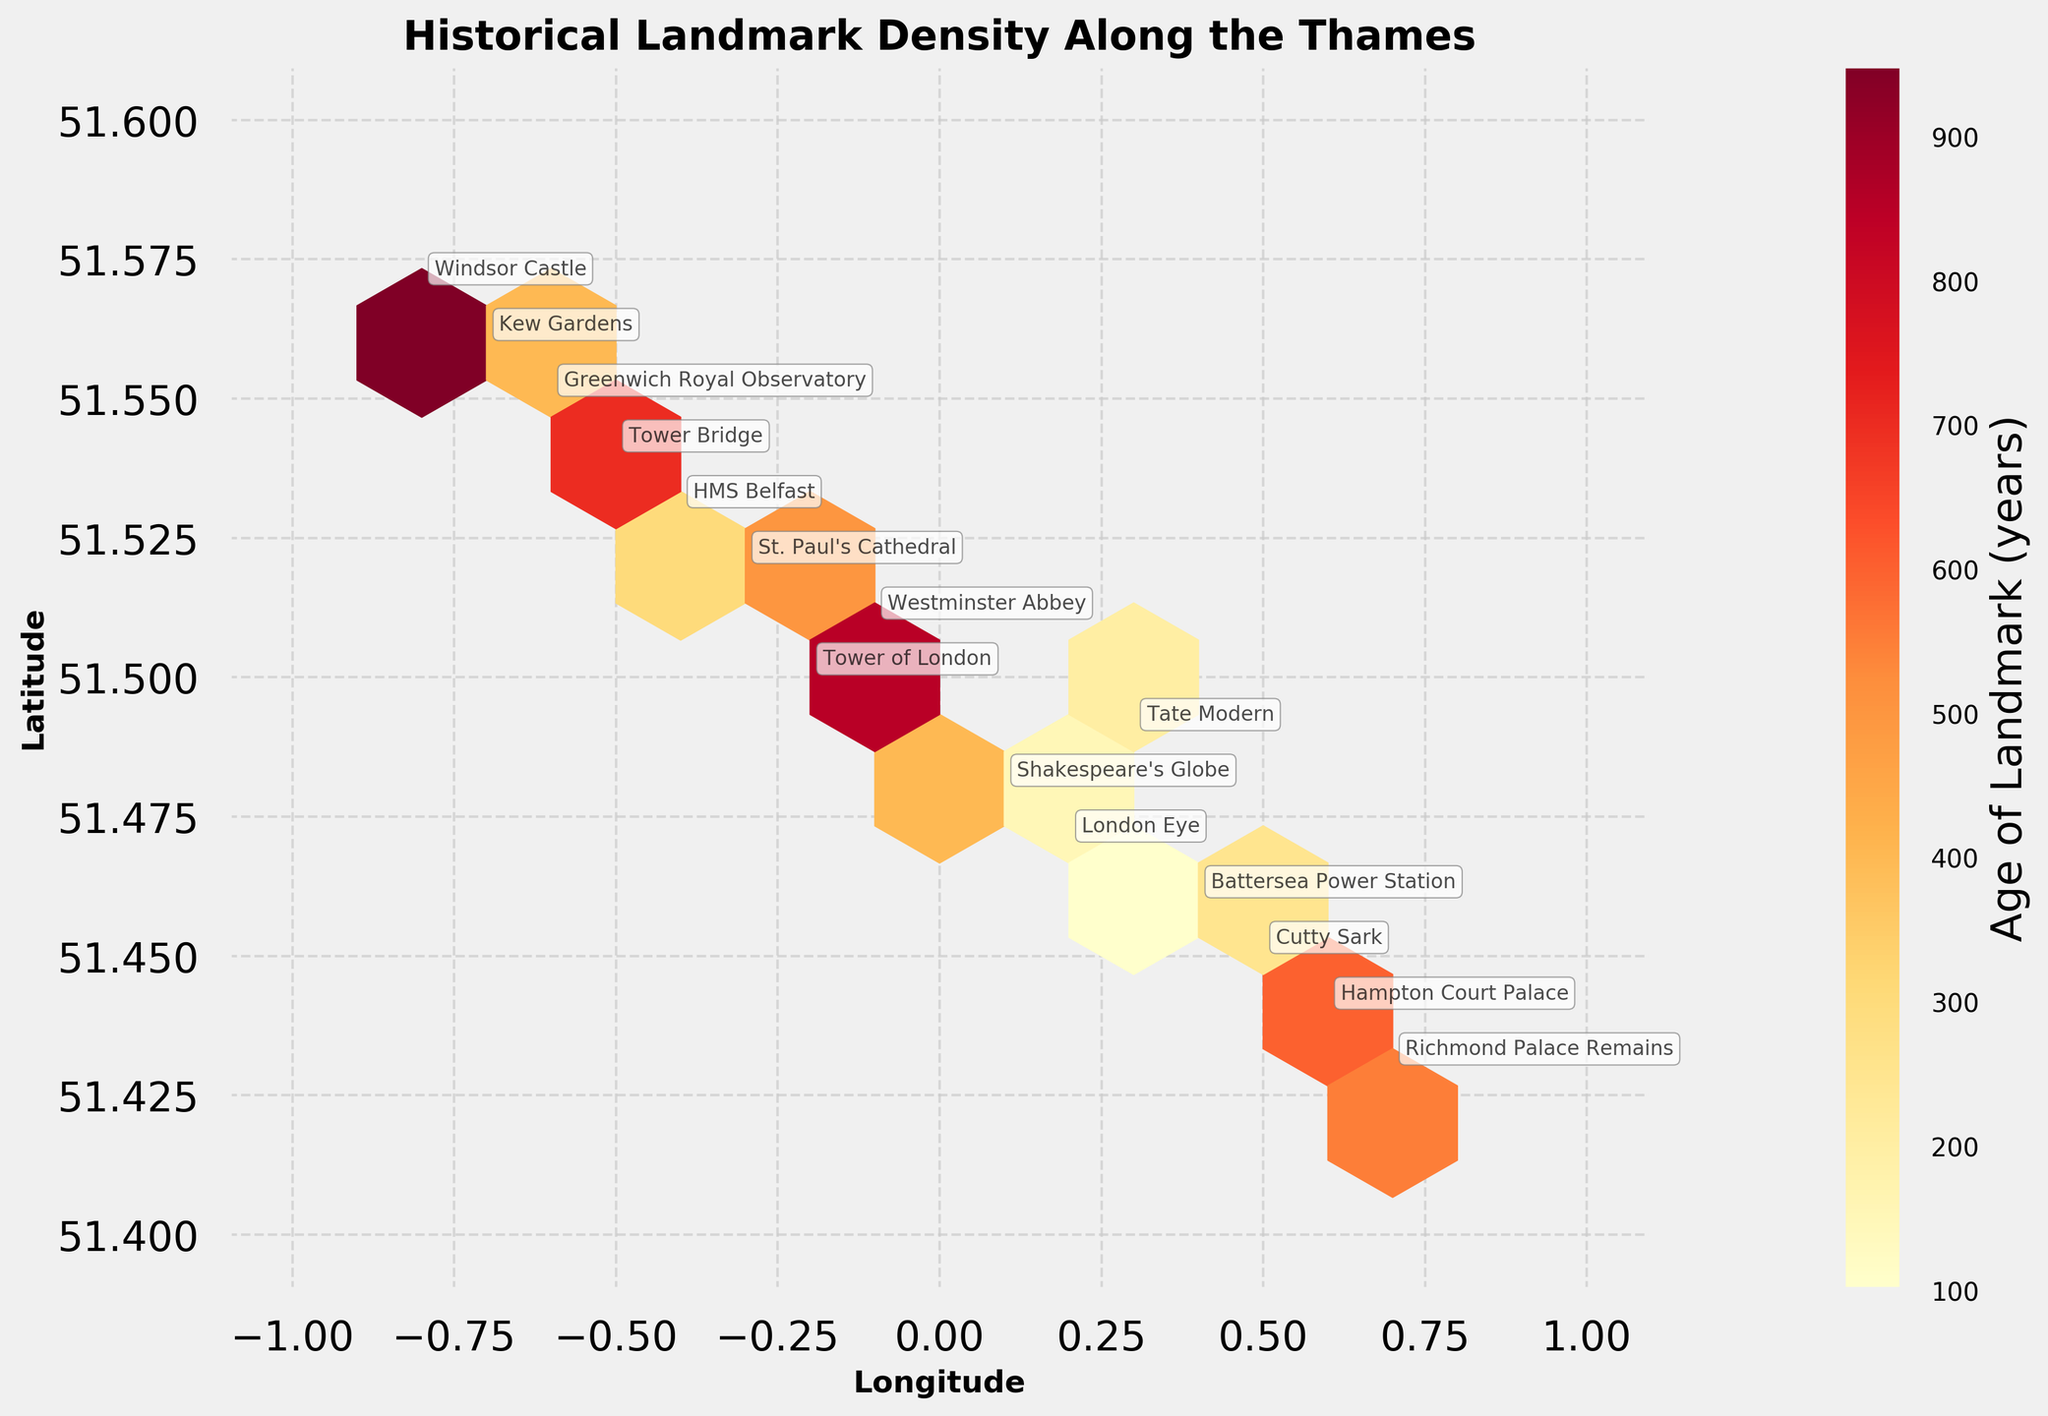What is the latitude range covered by the landmarks in the figure? The latitude range is shown on the y-axis in the plot. The landmarks span from 51.4 to 51.6 in latitude.
Answer: 51.4 to 51.6 How many historical landmarks are displayed on the plot? The figure has annotations for each historical landmark. Counting each labeled point gives us a total of 14 landmarks.
Answer: 14 Which landmark is the oldest? From the annotations and the age corresponding to each landmark, Windsor Castle (with an age of 950 years) is the oldest landmark.
Answer: Windsor Castle What is the average age of the landmarks around latitude 51.5? Using the annotations, the landmarks around latitude 51.5 include Tower of London (800 years), Shakespeare's Globe (400 years), Westminster Abbey (900 years), and St. Paul's Cathedral (500 years). The average age is (800 + 400 + 900 + 500) / 4 = 650 years.
Answer: 650 years Which landmark is located at the furthest east longitude? The plot shows that Richmond Palace Remains, located at longitude 0.7, is the furthest east.
Answer: Richmond Palace Remains Where is the highest density of historical landmarks on the plot? The hexbin plot color intensity shows the density. The area around longitude -0.1 and latitude 51.5 appears to have the highest density.
Answer: Around longitude -0.1 and latitude 51.5 Is the London Eye older or younger than Shakespeare's Globe? Referring to the annotations and the respective ages, the London Eye (150 years) is younger than Shakespeare's Globe (400 years).
Answer: Younger What is the combined age of Tower of London and Tower Bridge? The ages of the Tower of London and Tower Bridge are 800 and 700 years respectively. The combined age is 800 + 700 = 1500 years.
Answer: 1500 years Which landmark is located at the furthest west longitude? The plot shows that Windsor Castle, located at longitude -0.8, is the furthest west.
Answer: Windsor Castle 